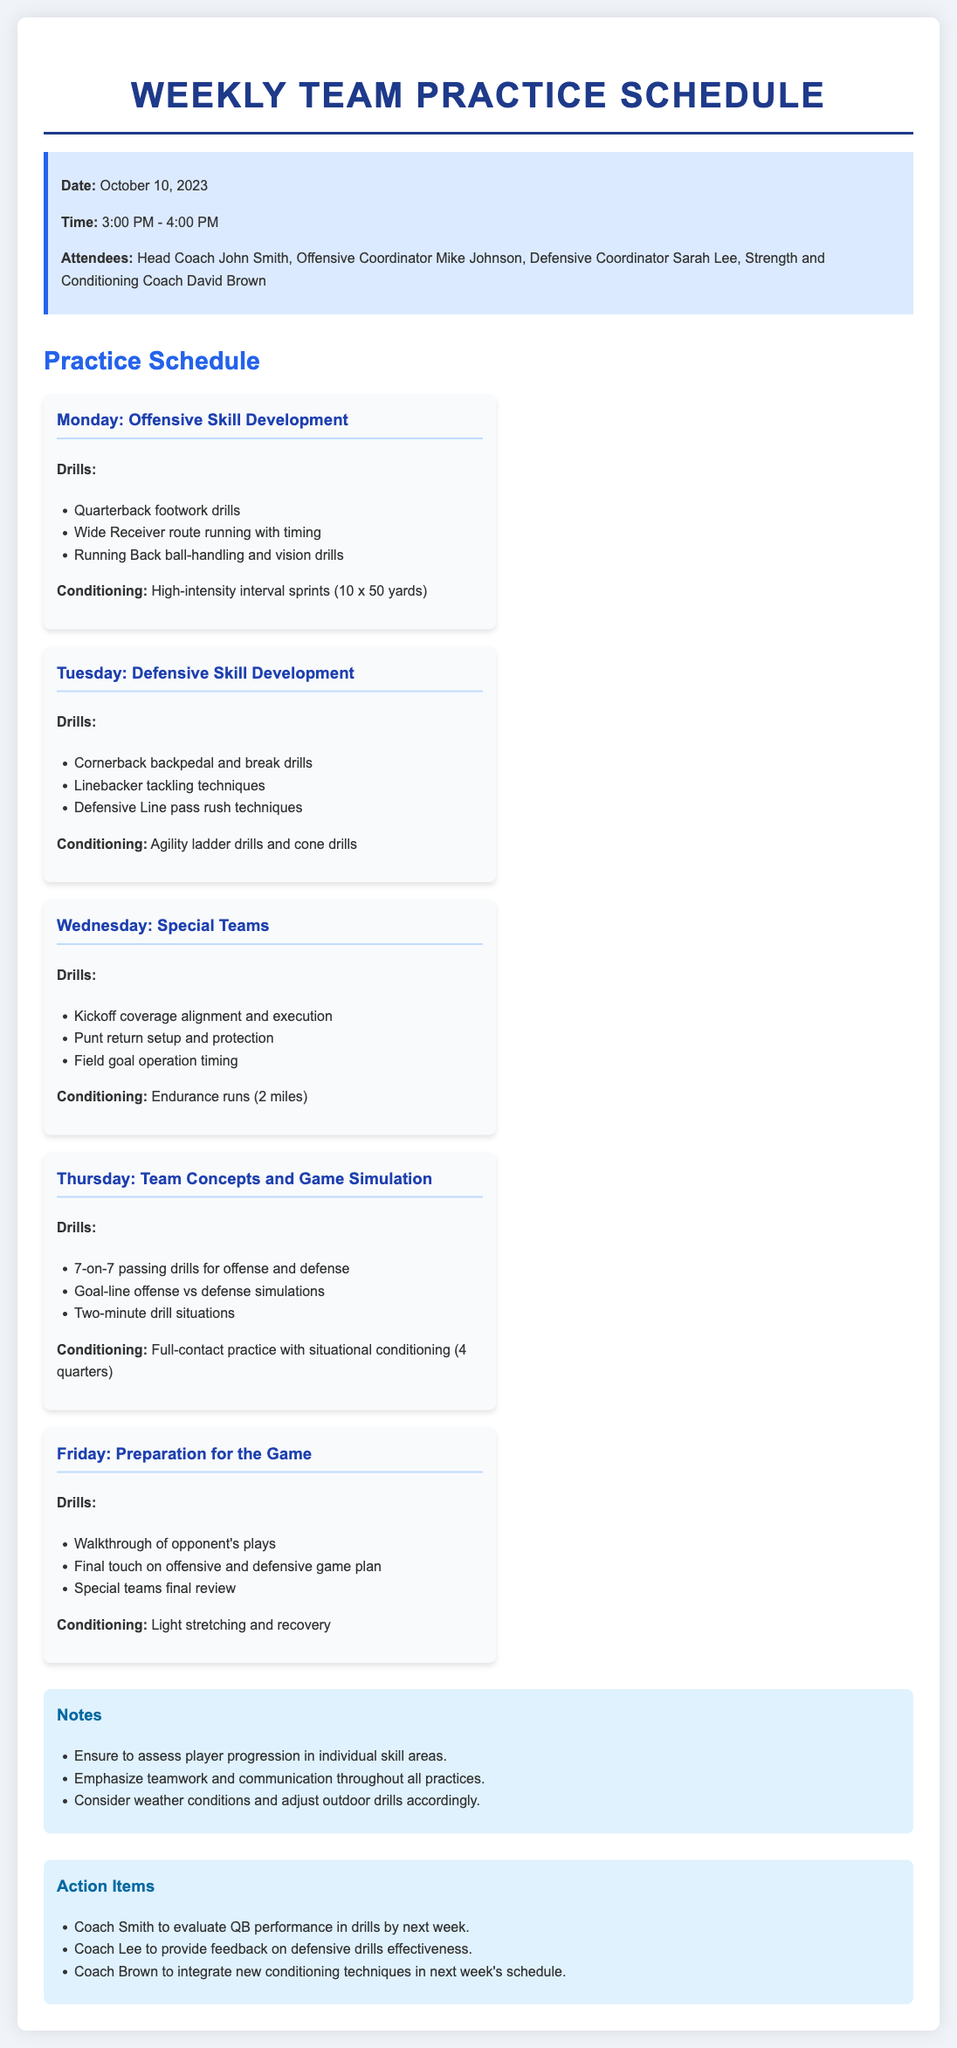What is the date of the meeting? The meeting is scheduled for October 10, 2023.
Answer: October 10, 2023 Who is the Head Coach? The document lists John Smith as the Head Coach.
Answer: John Smith What time does the practice start? The practice begins at 3:00 PM as noted in the document.
Answer: 3:00 PM What type of conditioning is scheduled for Monday? The document specifies high-intensity interval sprints for Monday's conditioning.
Answer: High-intensity interval sprints What drills are included for Wednesday's practice? The drills listed for Wednesday include kickoff coverage alignment and execution, punt return setup, and field goal operation timing.
Answer: Kickoff coverage alignment and execution, punt return setup, field goal operation timing Which day focuses on preparation for the game? The document indicates that Friday is focused on preparation for the game.
Answer: Friday What is one note mentioned in the meeting minutes? One note emphasized assessing player progression in individual skill areas.
Answer: Assess player progression in individual skill areas Who is tasked with evaluating quarterback performance? The document states that Coach Smith is to evaluate QB performance by next week.
Answer: Coach Smith What is one action item related to conditioning? Coach Brown is to integrate new conditioning techniques in next week's schedule according to the action items.
Answer: Integrate new conditioning techniques 